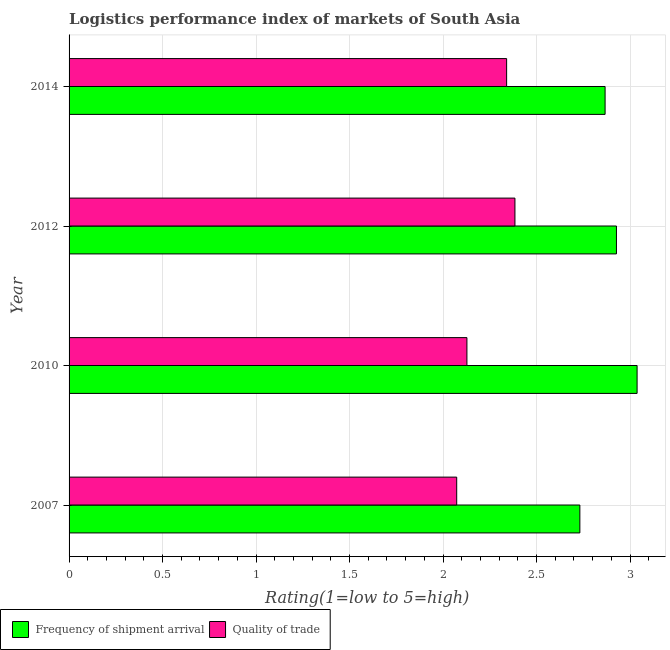Are the number of bars per tick equal to the number of legend labels?
Offer a terse response. Yes. What is the label of the 3rd group of bars from the top?
Keep it short and to the point. 2010. What is the lpi of frequency of shipment arrival in 2014?
Your answer should be very brief. 2.87. Across all years, what is the maximum lpi of frequency of shipment arrival?
Your response must be concise. 3.04. Across all years, what is the minimum lpi quality of trade?
Your response must be concise. 2.07. In which year was the lpi of frequency of shipment arrival maximum?
Provide a succinct answer. 2010. What is the total lpi of frequency of shipment arrival in the graph?
Ensure brevity in your answer.  11.56. What is the difference between the lpi quality of trade in 2012 and that in 2014?
Provide a short and direct response. 0.04. What is the difference between the lpi quality of trade in 2010 and the lpi of frequency of shipment arrival in 2007?
Provide a short and direct response. -0.6. What is the average lpi quality of trade per year?
Make the answer very short. 2.23. In the year 2012, what is the difference between the lpi quality of trade and lpi of frequency of shipment arrival?
Your answer should be compact. -0.54. What is the ratio of the lpi of frequency of shipment arrival in 2007 to that in 2012?
Provide a succinct answer. 0.93. Is the difference between the lpi quality of trade in 2012 and 2014 greater than the difference between the lpi of frequency of shipment arrival in 2012 and 2014?
Offer a very short reply. No. What is the difference between the highest and the second highest lpi quality of trade?
Your answer should be very brief. 0.04. What is the difference between the highest and the lowest lpi quality of trade?
Give a very brief answer. 0.31. Is the sum of the lpi quality of trade in 2010 and 2014 greater than the maximum lpi of frequency of shipment arrival across all years?
Your answer should be very brief. Yes. What does the 1st bar from the top in 2014 represents?
Provide a short and direct response. Quality of trade. What does the 1st bar from the bottom in 2014 represents?
Provide a short and direct response. Frequency of shipment arrival. Are all the bars in the graph horizontal?
Provide a short and direct response. Yes. How many years are there in the graph?
Provide a succinct answer. 4. Are the values on the major ticks of X-axis written in scientific E-notation?
Your answer should be very brief. No. Does the graph contain any zero values?
Your answer should be compact. No. Where does the legend appear in the graph?
Make the answer very short. Bottom left. How many legend labels are there?
Give a very brief answer. 2. What is the title of the graph?
Make the answer very short. Logistics performance index of markets of South Asia. Does "Old" appear as one of the legend labels in the graph?
Provide a succinct answer. No. What is the label or title of the X-axis?
Provide a short and direct response. Rating(1=low to 5=high). What is the Rating(1=low to 5=high) of Frequency of shipment arrival in 2007?
Ensure brevity in your answer.  2.73. What is the Rating(1=low to 5=high) in Quality of trade in 2007?
Offer a terse response. 2.07. What is the Rating(1=low to 5=high) of Frequency of shipment arrival in 2010?
Offer a very short reply. 3.04. What is the Rating(1=low to 5=high) in Quality of trade in 2010?
Your response must be concise. 2.13. What is the Rating(1=low to 5=high) of Frequency of shipment arrival in 2012?
Provide a succinct answer. 2.93. What is the Rating(1=low to 5=high) of Quality of trade in 2012?
Keep it short and to the point. 2.38. What is the Rating(1=low to 5=high) of Frequency of shipment arrival in 2014?
Offer a terse response. 2.87. What is the Rating(1=low to 5=high) in Quality of trade in 2014?
Provide a succinct answer. 2.34. Across all years, what is the maximum Rating(1=low to 5=high) in Frequency of shipment arrival?
Give a very brief answer. 3.04. Across all years, what is the maximum Rating(1=low to 5=high) of Quality of trade?
Your response must be concise. 2.38. Across all years, what is the minimum Rating(1=low to 5=high) in Frequency of shipment arrival?
Offer a very short reply. 2.73. Across all years, what is the minimum Rating(1=low to 5=high) in Quality of trade?
Make the answer very short. 2.07. What is the total Rating(1=low to 5=high) in Frequency of shipment arrival in the graph?
Provide a short and direct response. 11.56. What is the total Rating(1=low to 5=high) in Quality of trade in the graph?
Your response must be concise. 8.92. What is the difference between the Rating(1=low to 5=high) in Frequency of shipment arrival in 2007 and that in 2010?
Offer a very short reply. -0.31. What is the difference between the Rating(1=low to 5=high) of Quality of trade in 2007 and that in 2010?
Provide a short and direct response. -0.05. What is the difference between the Rating(1=low to 5=high) of Frequency of shipment arrival in 2007 and that in 2012?
Offer a terse response. -0.2. What is the difference between the Rating(1=low to 5=high) of Quality of trade in 2007 and that in 2012?
Ensure brevity in your answer.  -0.31. What is the difference between the Rating(1=low to 5=high) in Frequency of shipment arrival in 2007 and that in 2014?
Your response must be concise. -0.14. What is the difference between the Rating(1=low to 5=high) of Quality of trade in 2007 and that in 2014?
Keep it short and to the point. -0.27. What is the difference between the Rating(1=low to 5=high) in Frequency of shipment arrival in 2010 and that in 2012?
Provide a short and direct response. 0.11. What is the difference between the Rating(1=low to 5=high) of Quality of trade in 2010 and that in 2012?
Give a very brief answer. -0.26. What is the difference between the Rating(1=low to 5=high) of Frequency of shipment arrival in 2010 and that in 2014?
Your answer should be very brief. 0.17. What is the difference between the Rating(1=low to 5=high) in Quality of trade in 2010 and that in 2014?
Give a very brief answer. -0.21. What is the difference between the Rating(1=low to 5=high) of Frequency of shipment arrival in 2012 and that in 2014?
Keep it short and to the point. 0.06. What is the difference between the Rating(1=low to 5=high) in Quality of trade in 2012 and that in 2014?
Your response must be concise. 0.04. What is the difference between the Rating(1=low to 5=high) of Frequency of shipment arrival in 2007 and the Rating(1=low to 5=high) of Quality of trade in 2010?
Your response must be concise. 0.6. What is the difference between the Rating(1=low to 5=high) in Frequency of shipment arrival in 2007 and the Rating(1=low to 5=high) in Quality of trade in 2012?
Offer a terse response. 0.35. What is the difference between the Rating(1=low to 5=high) in Frequency of shipment arrival in 2007 and the Rating(1=low to 5=high) in Quality of trade in 2014?
Your response must be concise. 0.39. What is the difference between the Rating(1=low to 5=high) in Frequency of shipment arrival in 2010 and the Rating(1=low to 5=high) in Quality of trade in 2012?
Make the answer very short. 0.65. What is the difference between the Rating(1=low to 5=high) of Frequency of shipment arrival in 2010 and the Rating(1=low to 5=high) of Quality of trade in 2014?
Offer a very short reply. 0.7. What is the difference between the Rating(1=low to 5=high) of Frequency of shipment arrival in 2012 and the Rating(1=low to 5=high) of Quality of trade in 2014?
Provide a succinct answer. 0.59. What is the average Rating(1=low to 5=high) in Frequency of shipment arrival per year?
Offer a terse response. 2.89. What is the average Rating(1=low to 5=high) in Quality of trade per year?
Your response must be concise. 2.23. In the year 2007, what is the difference between the Rating(1=low to 5=high) of Frequency of shipment arrival and Rating(1=low to 5=high) of Quality of trade?
Keep it short and to the point. 0.66. In the year 2010, what is the difference between the Rating(1=low to 5=high) in Frequency of shipment arrival and Rating(1=low to 5=high) in Quality of trade?
Ensure brevity in your answer.  0.91. In the year 2012, what is the difference between the Rating(1=low to 5=high) of Frequency of shipment arrival and Rating(1=low to 5=high) of Quality of trade?
Your answer should be compact. 0.54. In the year 2014, what is the difference between the Rating(1=low to 5=high) of Frequency of shipment arrival and Rating(1=low to 5=high) of Quality of trade?
Offer a terse response. 0.53. What is the ratio of the Rating(1=low to 5=high) of Frequency of shipment arrival in 2007 to that in 2010?
Your response must be concise. 0.9. What is the ratio of the Rating(1=low to 5=high) in Quality of trade in 2007 to that in 2010?
Provide a short and direct response. 0.97. What is the ratio of the Rating(1=low to 5=high) in Frequency of shipment arrival in 2007 to that in 2012?
Keep it short and to the point. 0.93. What is the ratio of the Rating(1=low to 5=high) in Quality of trade in 2007 to that in 2012?
Offer a terse response. 0.87. What is the ratio of the Rating(1=low to 5=high) of Frequency of shipment arrival in 2007 to that in 2014?
Ensure brevity in your answer.  0.95. What is the ratio of the Rating(1=low to 5=high) of Quality of trade in 2007 to that in 2014?
Your answer should be compact. 0.89. What is the ratio of the Rating(1=low to 5=high) in Frequency of shipment arrival in 2010 to that in 2012?
Keep it short and to the point. 1.04. What is the ratio of the Rating(1=low to 5=high) of Quality of trade in 2010 to that in 2012?
Offer a very short reply. 0.89. What is the ratio of the Rating(1=low to 5=high) in Frequency of shipment arrival in 2010 to that in 2014?
Your answer should be compact. 1.06. What is the ratio of the Rating(1=low to 5=high) in Quality of trade in 2010 to that in 2014?
Provide a short and direct response. 0.91. What is the ratio of the Rating(1=low to 5=high) in Frequency of shipment arrival in 2012 to that in 2014?
Your answer should be compact. 1.02. What is the ratio of the Rating(1=low to 5=high) of Quality of trade in 2012 to that in 2014?
Provide a short and direct response. 1.02. What is the difference between the highest and the second highest Rating(1=low to 5=high) of Frequency of shipment arrival?
Offer a terse response. 0.11. What is the difference between the highest and the second highest Rating(1=low to 5=high) in Quality of trade?
Make the answer very short. 0.04. What is the difference between the highest and the lowest Rating(1=low to 5=high) in Frequency of shipment arrival?
Make the answer very short. 0.31. What is the difference between the highest and the lowest Rating(1=low to 5=high) in Quality of trade?
Ensure brevity in your answer.  0.31. 